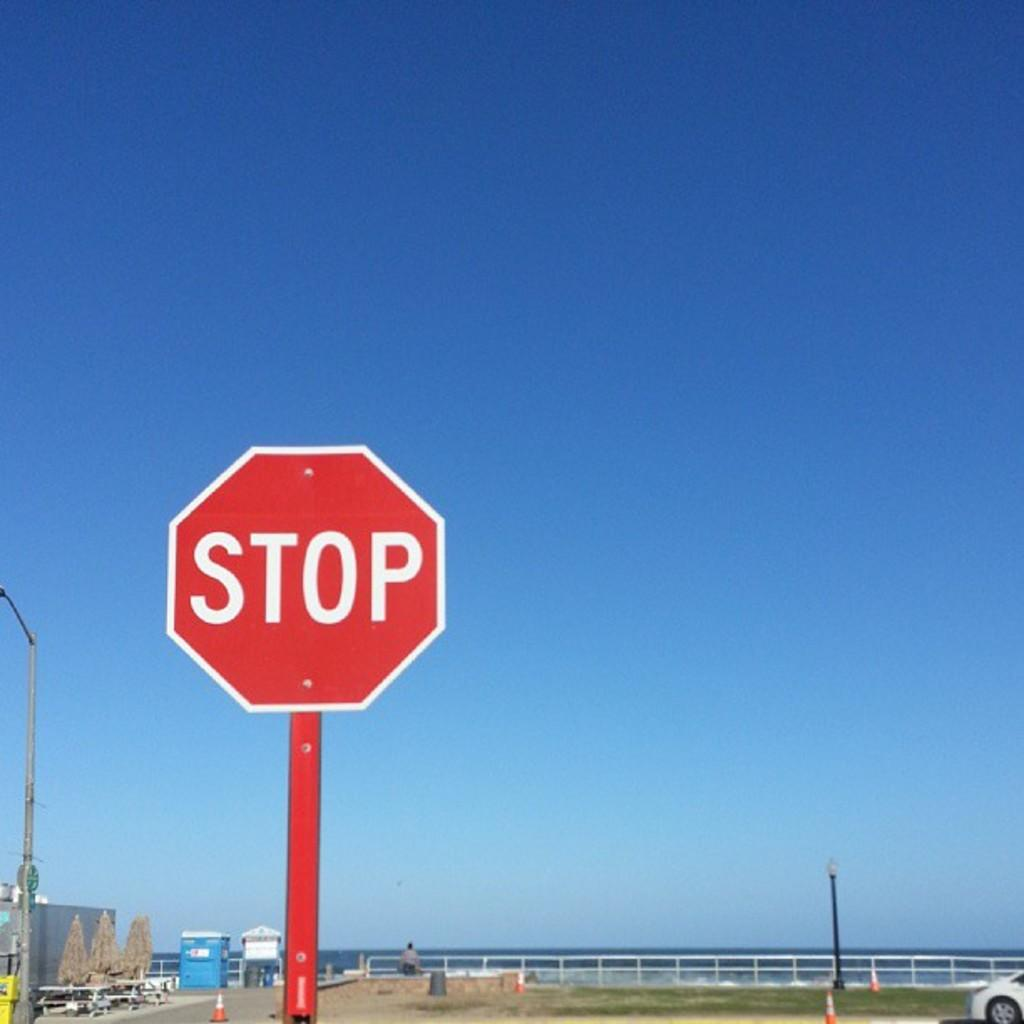<image>
Present a compact description of the photo's key features. A octagon sign and a red pole with STOP in white lettering. 